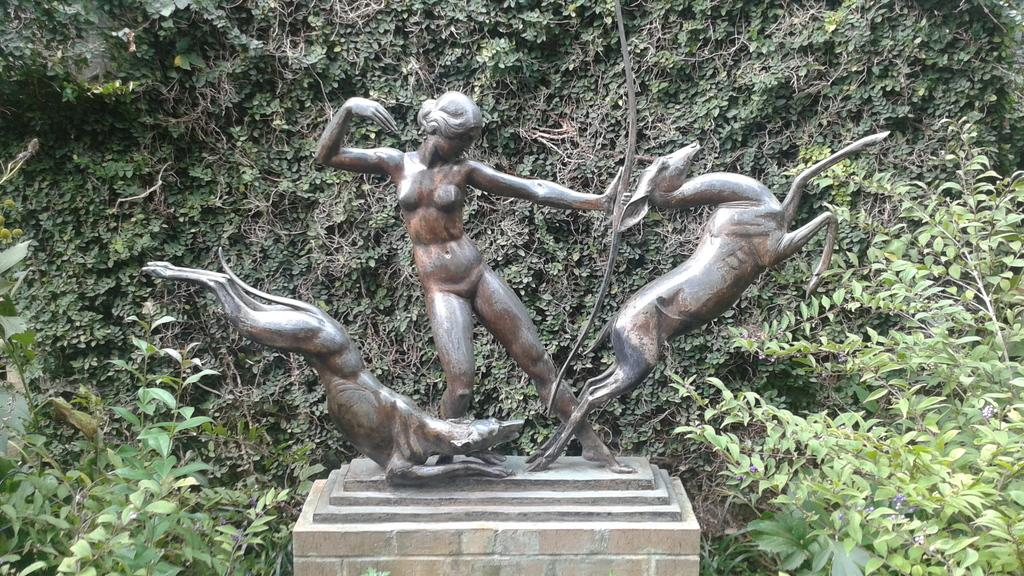What can be seen in the image that resembles a person or figure? There are statues in the image that resemble a person or figure. What is the statues placed on in the image? The statues are on an object in the image. What type of vegetation is present in the image? There are plants in the image. How much waste is being produced by the statues in the image? There is no indication of waste production by the statues in the image, as statues are inanimate objects. What type of knowledge can be gained from observing the statues in the image? The image does not provide any specific knowledge or insight about the statues; it simply shows their presence and location. 